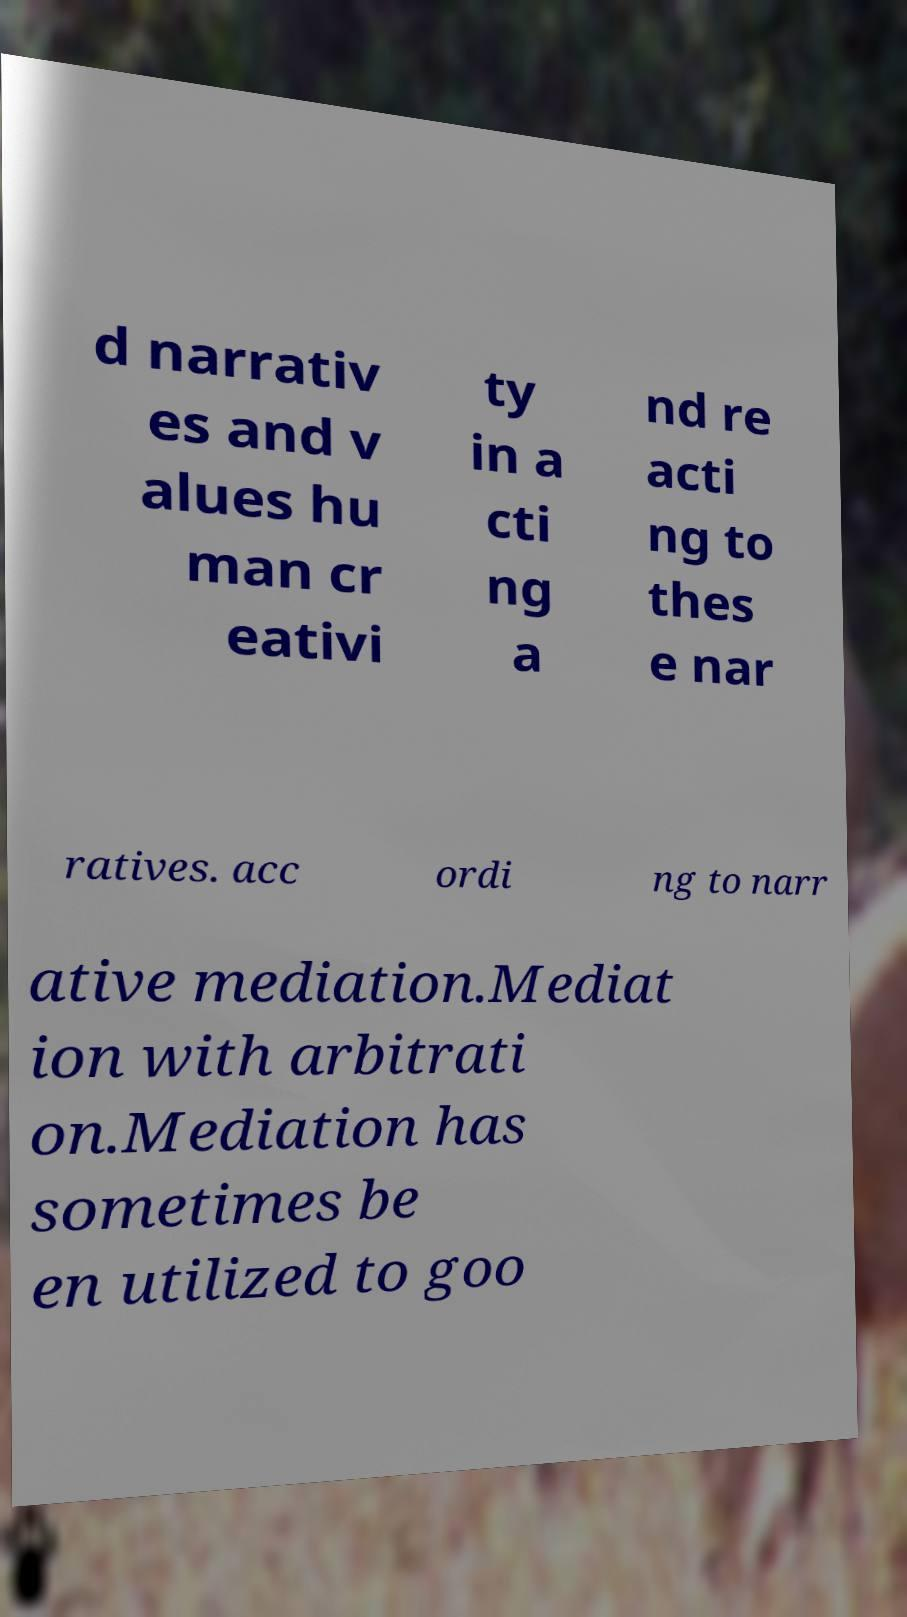Could you extract and type out the text from this image? d narrativ es and v alues hu man cr eativi ty in a cti ng a nd re acti ng to thes e nar ratives. acc ordi ng to narr ative mediation.Mediat ion with arbitrati on.Mediation has sometimes be en utilized to goo 